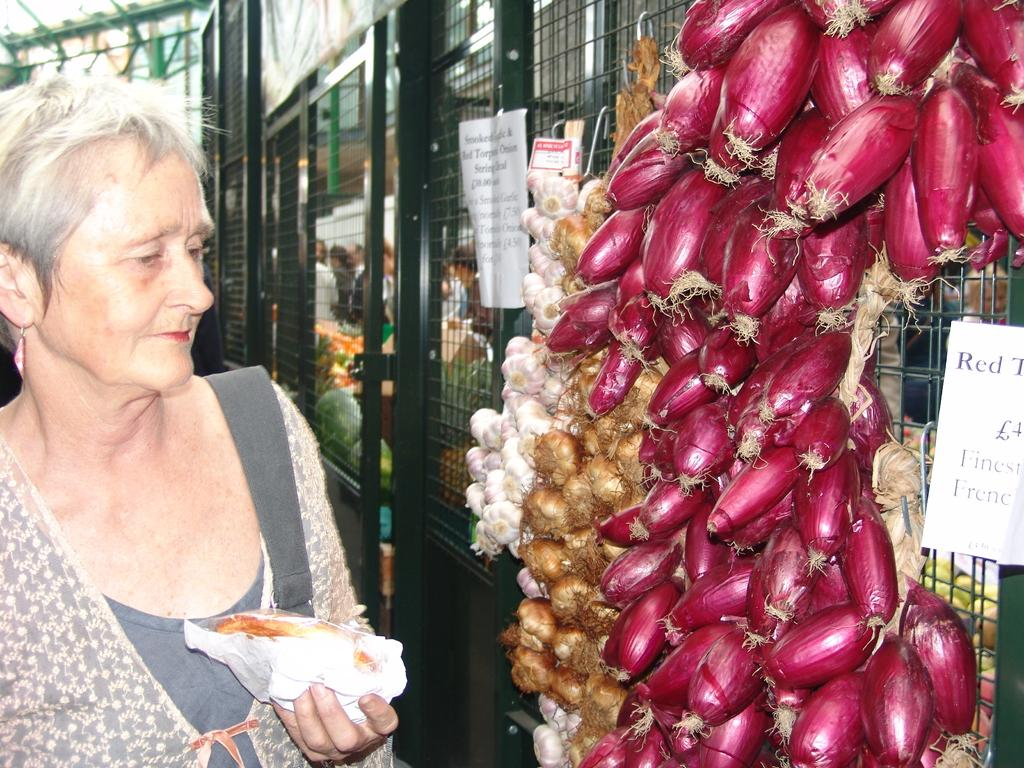Who is the main subject in the image? There is a woman in the image. What is the woman holding in the image? The woman is holding a food item. What type of food item is the woman holding? The food item is not specified, but it is mentioned that there are vegetables in the image. What else can be seen in the image besides the woman and the food item? There is a grille, papers, and other people in the image. What is the name of the cushion in the image? There is no cushion present in the image. 